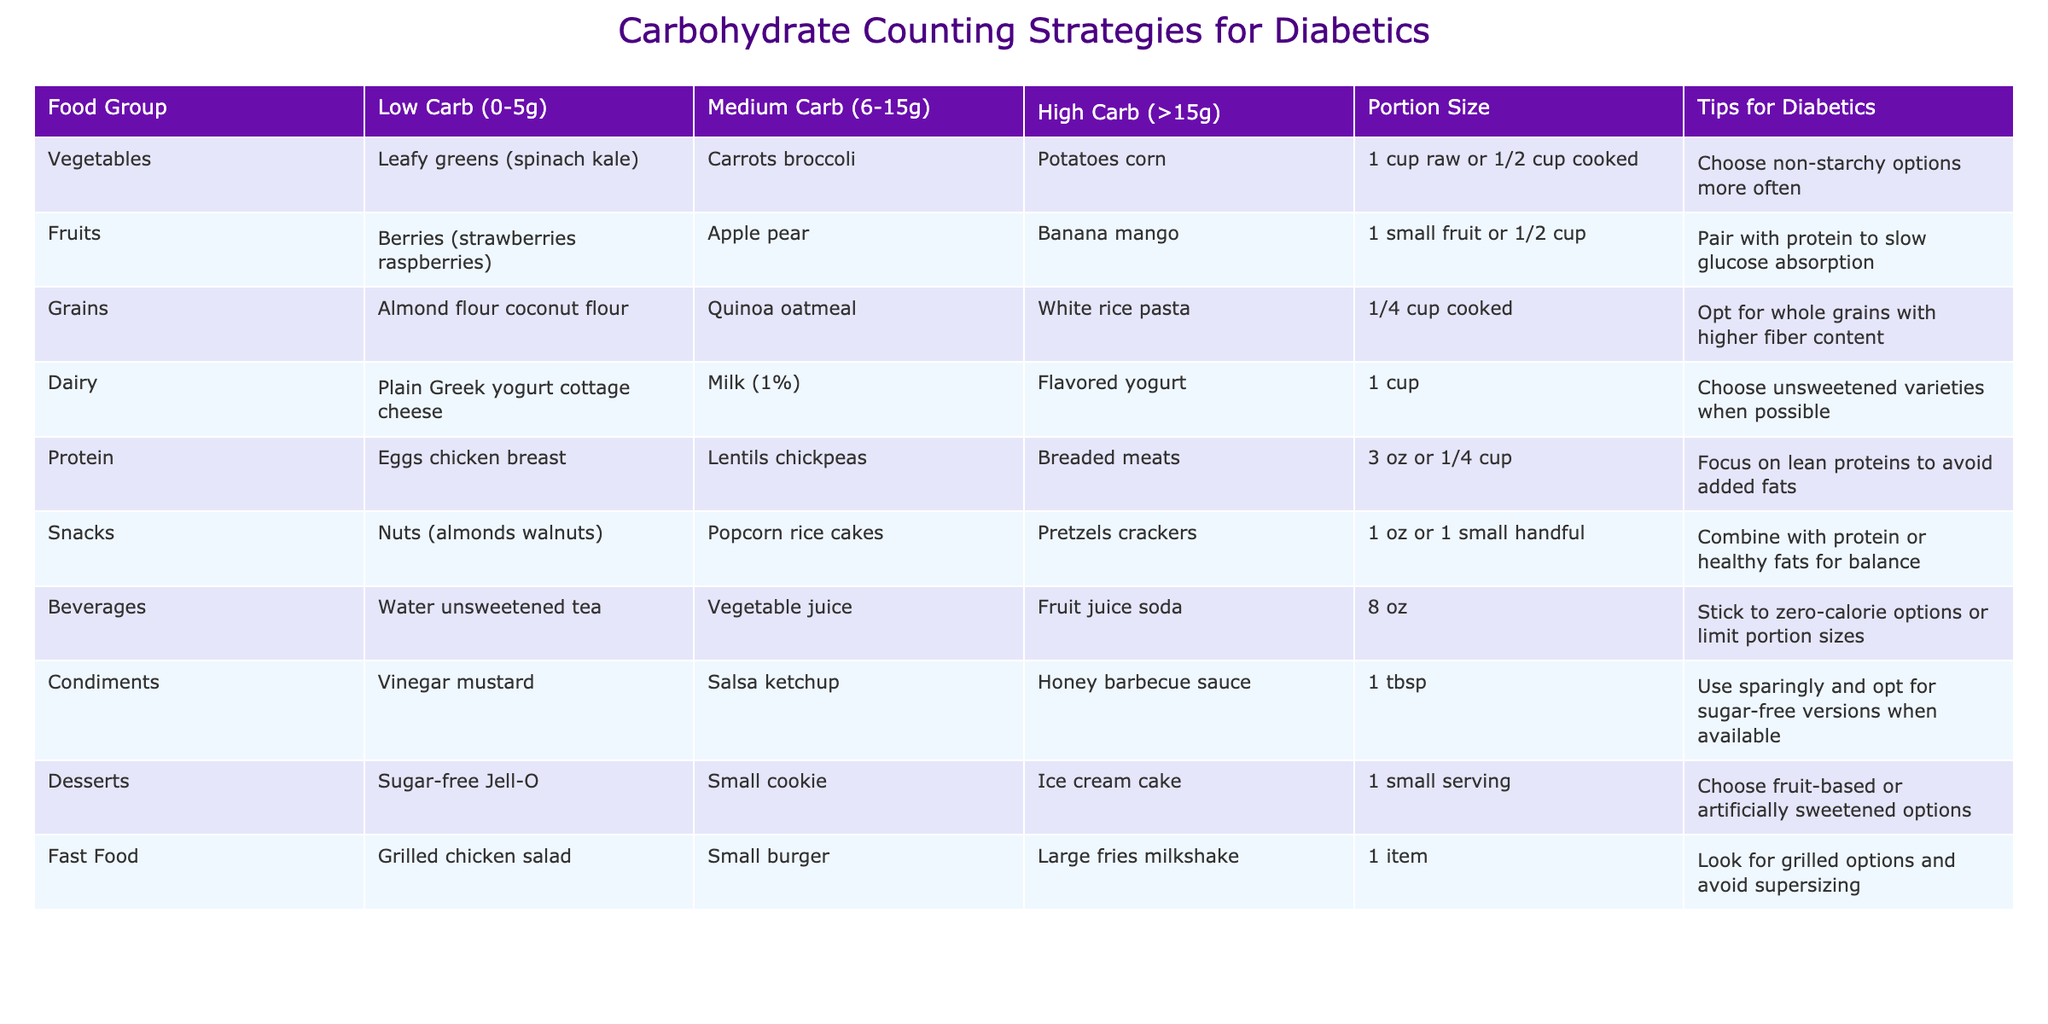What are examples of low-carb vegetables? According to the table, examples of low-carb vegetables include leafy greens such as spinach and kale.
Answer: Leafy greens (spinach, kale) What is the portion size for fruits? The table states that the portion size for fruits is 1 small fruit or 1/2 cup.
Answer: 1 small fruit or 1/2 cup Are breads considered a high-carb protein source? The table categorizes breaded meats (which contain bread) under high-carb proteins. Therefore, the statement is true.
Answer: Yes What is the difference in portion size for dairy and snacks? The portion size for dairy is 1 cup, while the portion size for snacks is 1 oz or 1 small handful. Therefore, the difference is that dairy is typically a larger portion size.
Answer: 1 cup for dairy and 1 oz for snacks Which food group has the highest carb options in the table? The food group with the highest carb options is grains, which includes white rice and pasta with more than 15g of carbs.
Answer: Grains If I consume 1 cup of flavored yogurt, how many grams of carbohydrates am I consuming? Flavored yogurt is categorized as high carb, which is greater than 15g for 1 cup according to the table. Therefore, consuming 1 cup would give you more than 15g of carbohydrates.
Answer: More than 15g What portions can be combined with protein for balance among snacks? The table suggests combining nuts, which are low-carb snacks, with protein or healthy fats for balance.
Answer: Nuts with protein or healthy fats Is it advisable to drink fruit juice according to the strategies shown? Since fruit juice is listed under medium carb beverages, it is not recommended unless you limit the portion size. This leads to a "no" answer to the advisability without caution.
Answer: No Which food groups suggest opting for unsweetened varieties? Dairy, specifically plain Greek yogurt and cottage cheese, suggests choosing unsweetened varieties, and condiments, like sugar-free sauces, also recommend unsweetened versions.
Answer: Dairy and condiments 